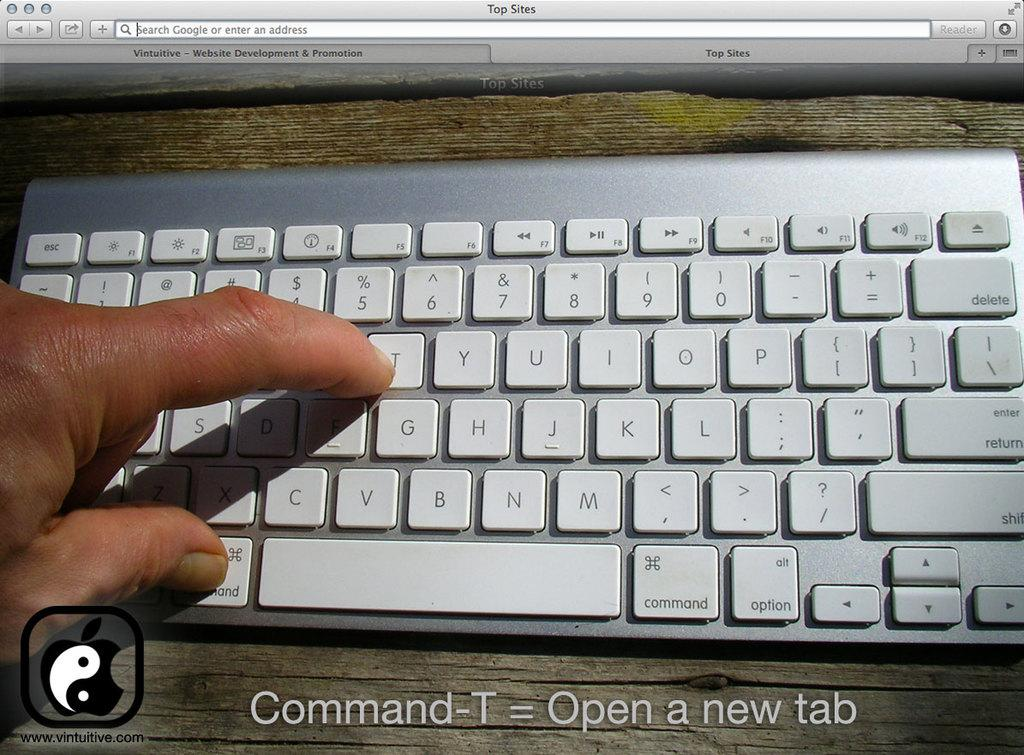Provide a one-sentence caption for the provided image. A person demonstrating on a keyboard the Command-T function that opens a new tab. 